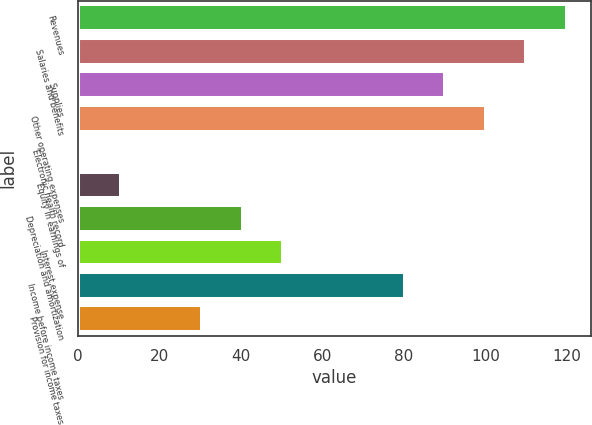Convert chart. <chart><loc_0><loc_0><loc_500><loc_500><bar_chart><fcel>Revenues<fcel>Salaries and benefits<fcel>Supplies<fcel>Other operating expenses<fcel>Electronic health record<fcel>Equity in earnings of<fcel>Depreciation and amortization<fcel>Interest expense<fcel>Income before income taxes<fcel>Provision for income taxes<nl><fcel>119.86<fcel>109.93<fcel>90.07<fcel>100<fcel>0.7<fcel>10.63<fcel>40.42<fcel>50.35<fcel>80.14<fcel>30.49<nl></chart> 